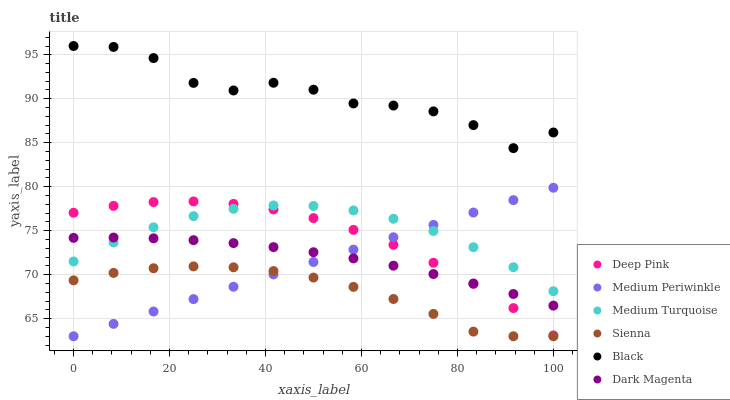Does Sienna have the minimum area under the curve?
Answer yes or no. Yes. Does Black have the maximum area under the curve?
Answer yes or no. Yes. Does Dark Magenta have the minimum area under the curve?
Answer yes or no. No. Does Dark Magenta have the maximum area under the curve?
Answer yes or no. No. Is Medium Periwinkle the smoothest?
Answer yes or no. Yes. Is Black the roughest?
Answer yes or no. Yes. Is Dark Magenta the smoothest?
Answer yes or no. No. Is Dark Magenta the roughest?
Answer yes or no. No. Does Medium Periwinkle have the lowest value?
Answer yes or no. Yes. Does Dark Magenta have the lowest value?
Answer yes or no. No. Does Black have the highest value?
Answer yes or no. Yes. Does Dark Magenta have the highest value?
Answer yes or no. No. Is Sienna less than Deep Pink?
Answer yes or no. Yes. Is Deep Pink greater than Sienna?
Answer yes or no. Yes. Does Medium Periwinkle intersect Medium Turquoise?
Answer yes or no. Yes. Is Medium Periwinkle less than Medium Turquoise?
Answer yes or no. No. Is Medium Periwinkle greater than Medium Turquoise?
Answer yes or no. No. Does Sienna intersect Deep Pink?
Answer yes or no. No. 